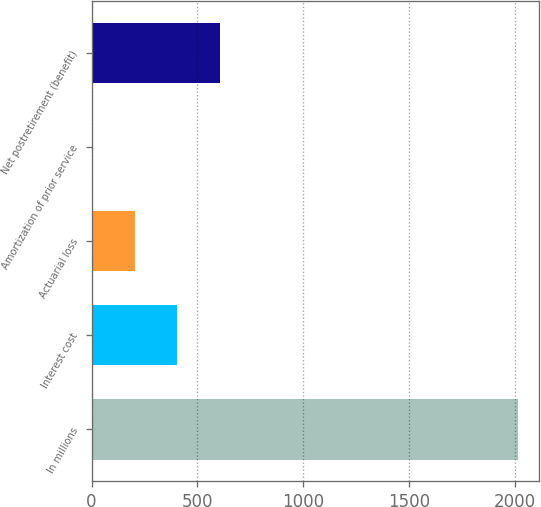<chart> <loc_0><loc_0><loc_500><loc_500><bar_chart><fcel>In millions<fcel>Interest cost<fcel>Actuarial loss<fcel>Amortization of prior service<fcel>Net postretirement (benefit)<nl><fcel>2016<fcel>406.4<fcel>205.2<fcel>4<fcel>607.6<nl></chart> 